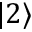Convert formula to latex. <formula><loc_0><loc_0><loc_500><loc_500>| 2 \rangle</formula> 